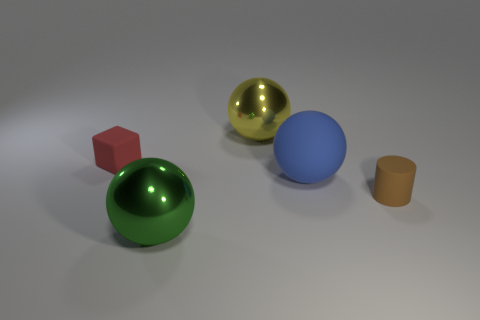What number of green spheres are behind the object to the left of the large green sphere?
Keep it short and to the point. 0. There is a rubber object that is on the left side of the metal ball that is behind the red block; are there any large objects that are in front of it?
Offer a very short reply. Yes. What material is the blue thing that is the same shape as the yellow object?
Make the answer very short. Rubber. Is the material of the small red thing the same as the large sphere on the left side of the yellow metallic object?
Your answer should be very brief. No. What shape is the matte thing that is left of the shiny object that is behind the blue object?
Make the answer very short. Cube. How many tiny objects are either yellow metal things or cyan shiny cylinders?
Make the answer very short. 0. How many large blue rubber objects have the same shape as the green thing?
Provide a succinct answer. 1. Does the blue rubber object have the same shape as the metal thing that is in front of the rubber sphere?
Offer a terse response. Yes. What number of big things are in front of the brown rubber thing?
Provide a succinct answer. 1. Are there any cubes of the same size as the brown rubber cylinder?
Provide a short and direct response. Yes. 